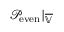<formula> <loc_0><loc_0><loc_500><loc_500>\mathcal { P } _ { e v e n } | _ { \overline { { \mathbb { V } } } }</formula> 